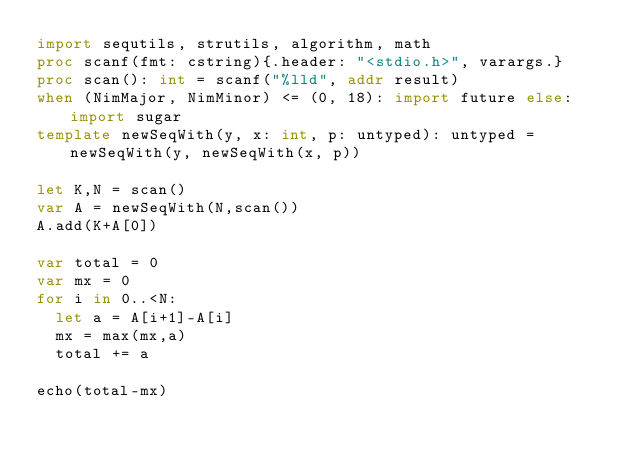<code> <loc_0><loc_0><loc_500><loc_500><_Nim_>import sequtils, strutils, algorithm, math
proc scanf(fmt: cstring){.header: "<stdio.h>", varargs.}
proc scan(): int = scanf("%lld", addr result)
when (NimMajor, NimMinor) <= (0, 18): import future else: import sugar
template newSeqWith(y, x: int, p: untyped): untyped = newSeqWith(y, newSeqWith(x, p))

let K,N = scan()
var A = newSeqWith(N,scan())
A.add(K+A[0])

var total = 0
var mx = 0
for i in 0..<N:
  let a = A[i+1]-A[i]
  mx = max(mx,a)
  total += a 

echo(total-mx)
</code> 